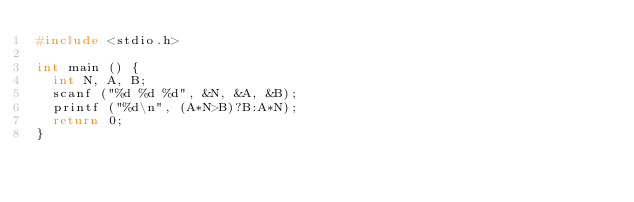Convert code to text. <code><loc_0><loc_0><loc_500><loc_500><_C_>#include <stdio.h>

int main () {
	int N, A, B;
	scanf ("%d %d %d", &N, &A, &B);
	printf ("%d\n", (A*N>B)?B:A*N);
	return 0;
}</code> 